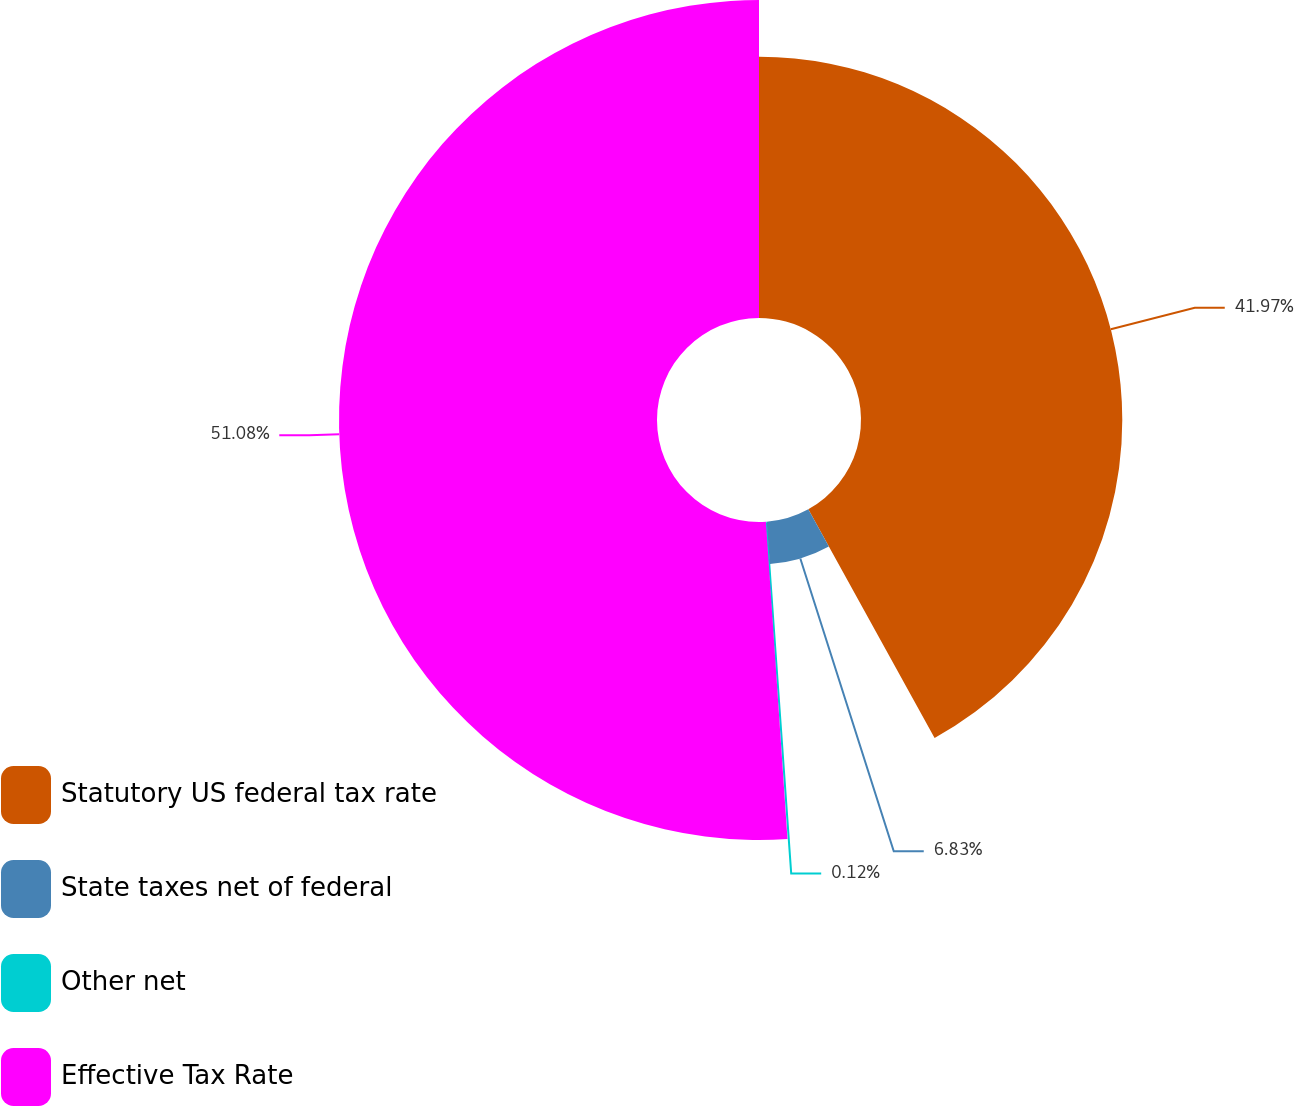<chart> <loc_0><loc_0><loc_500><loc_500><pie_chart><fcel>Statutory US federal tax rate<fcel>State taxes net of federal<fcel>Other net<fcel>Effective Tax Rate<nl><fcel>41.97%<fcel>6.83%<fcel>0.12%<fcel>51.08%<nl></chart> 